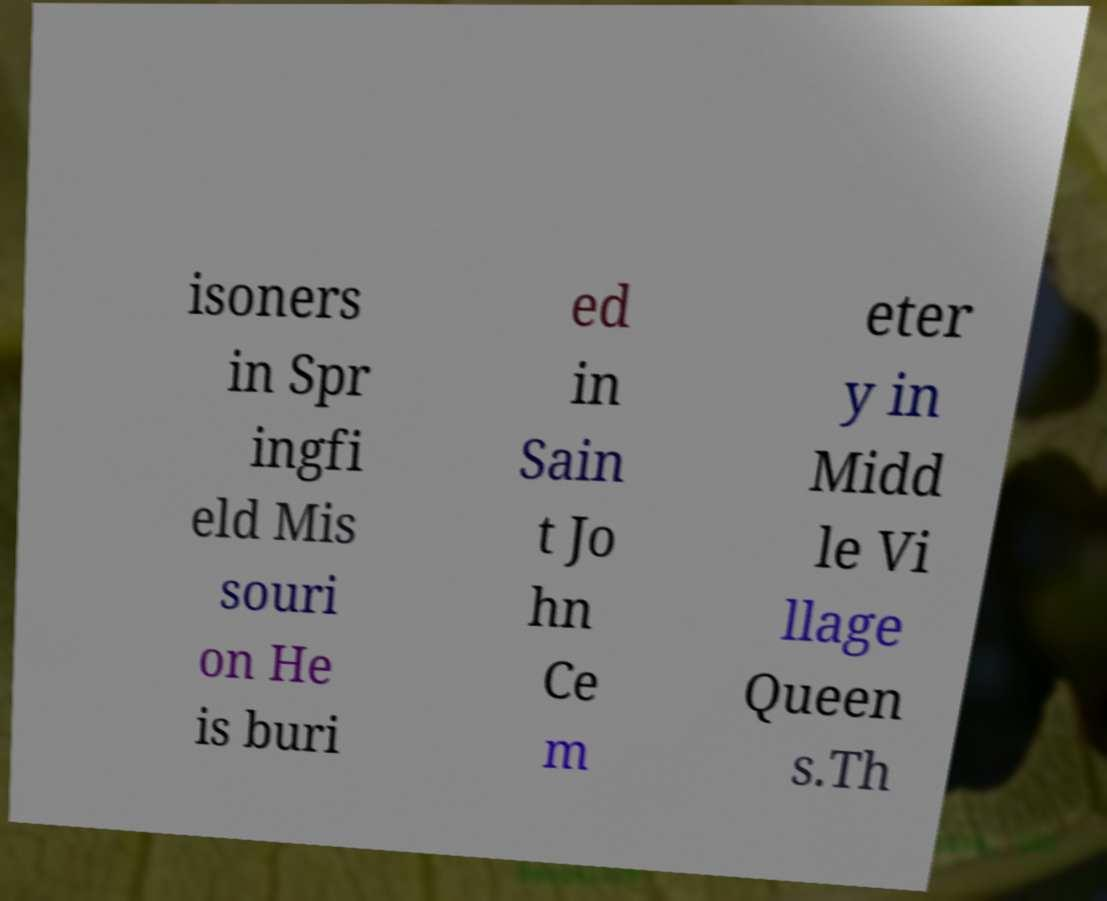Can you read and provide the text displayed in the image?This photo seems to have some interesting text. Can you extract and type it out for me? isoners in Spr ingfi eld Mis souri on He is buri ed in Sain t Jo hn Ce m eter y in Midd le Vi llage Queen s.Th 